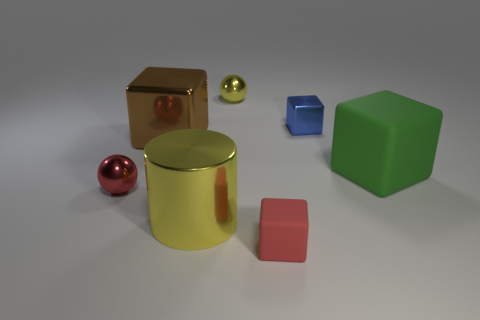There is a big metal cylinder; is it the same color as the sphere behind the tiny metal cube?
Your answer should be very brief. Yes. The metallic thing that is the same color as the big metallic cylinder is what size?
Provide a short and direct response. Small. Does the shiny cube that is in front of the blue shiny thing have the same size as the thing that is behind the blue metal block?
Give a very brief answer. No. What number of shiny balls are the same color as the large metallic cube?
Keep it short and to the point. 0. Are there more metallic things on the left side of the large yellow cylinder than metal things?
Your answer should be very brief. No. Do the small blue object and the large matte object have the same shape?
Give a very brief answer. Yes. How many red things are made of the same material as the tiny yellow ball?
Make the answer very short. 1. What is the size of the blue object that is the same shape as the brown object?
Your answer should be compact. Small. Does the blue cube have the same size as the yellow metallic ball?
Offer a terse response. Yes. What shape is the tiny red object that is right of the tiny metallic sphere that is behind the tiny block that is behind the red rubber cube?
Offer a terse response. Cube. 